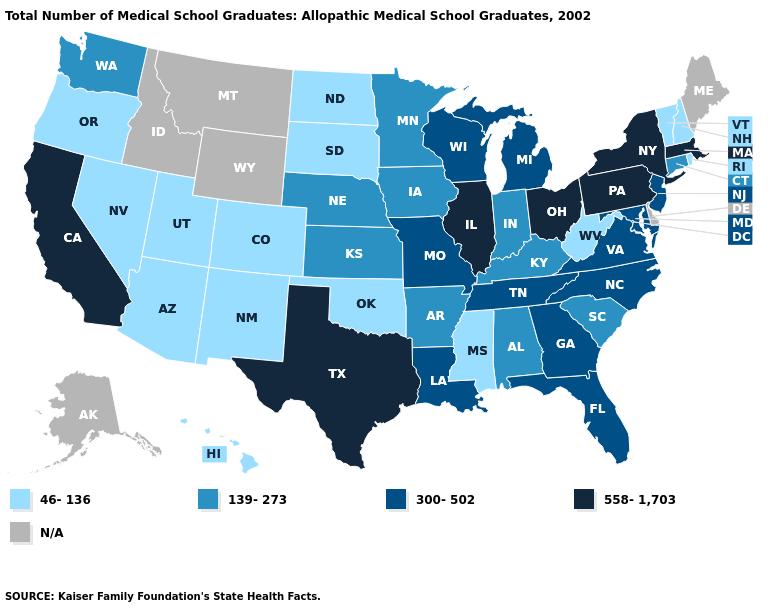Which states have the lowest value in the West?
Give a very brief answer. Arizona, Colorado, Hawaii, Nevada, New Mexico, Oregon, Utah. Among the states that border Missouri , does Nebraska have the highest value?
Be succinct. No. Does the map have missing data?
Concise answer only. Yes. What is the value of Texas?
Answer briefly. 558-1,703. Name the states that have a value in the range N/A?
Concise answer only. Alaska, Delaware, Idaho, Maine, Montana, Wyoming. What is the lowest value in the USA?
Short answer required. 46-136. What is the value of California?
Short answer required. 558-1,703. Does Colorado have the lowest value in the USA?
Keep it brief. Yes. What is the value of Wyoming?
Give a very brief answer. N/A. What is the value of Oklahoma?
Concise answer only. 46-136. What is the highest value in the USA?
Short answer required. 558-1,703. What is the lowest value in states that border Utah?
Be succinct. 46-136. What is the value of Florida?
Keep it brief. 300-502. Does the first symbol in the legend represent the smallest category?
Keep it brief. Yes. What is the value of North Carolina?
Concise answer only. 300-502. 